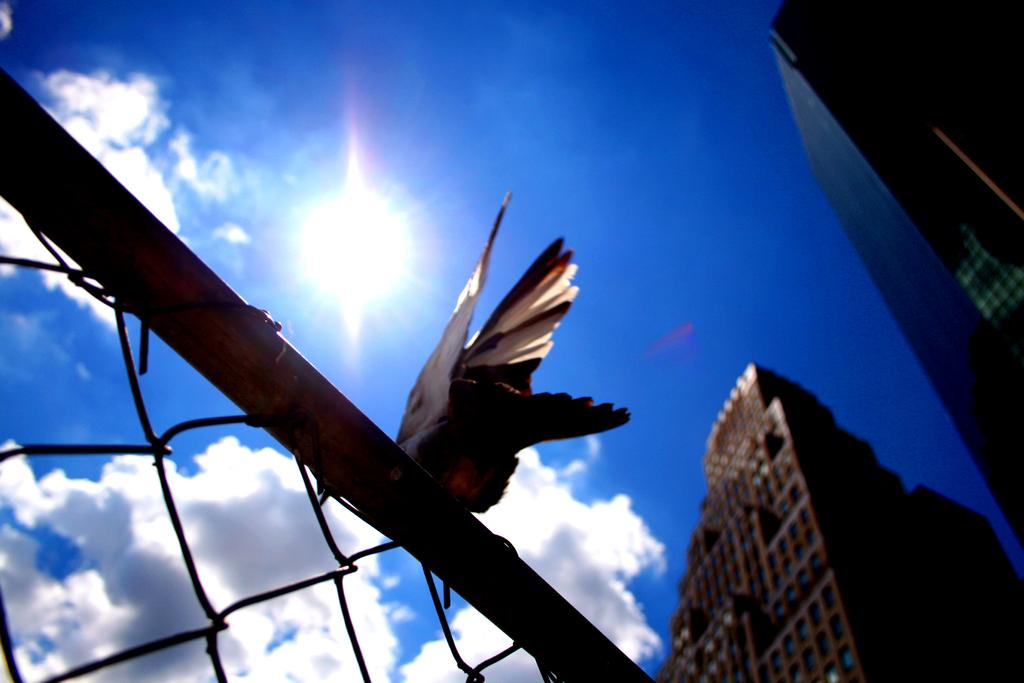What type of animal is in the image? There is a bird in the image. What colors can be seen on the bird? The bird is black and white in color. Where is the bird located in the image? The bird is on a metal rod. What other metal object can be seen in the image? There is metal fencing in the image. What is visible in the background of the image? Buildings and the sky are visible in the background of the image. What flavor of scarf is the bird wearing in the image? There is no scarf present in the image, and therefore no flavor can be associated with it. 